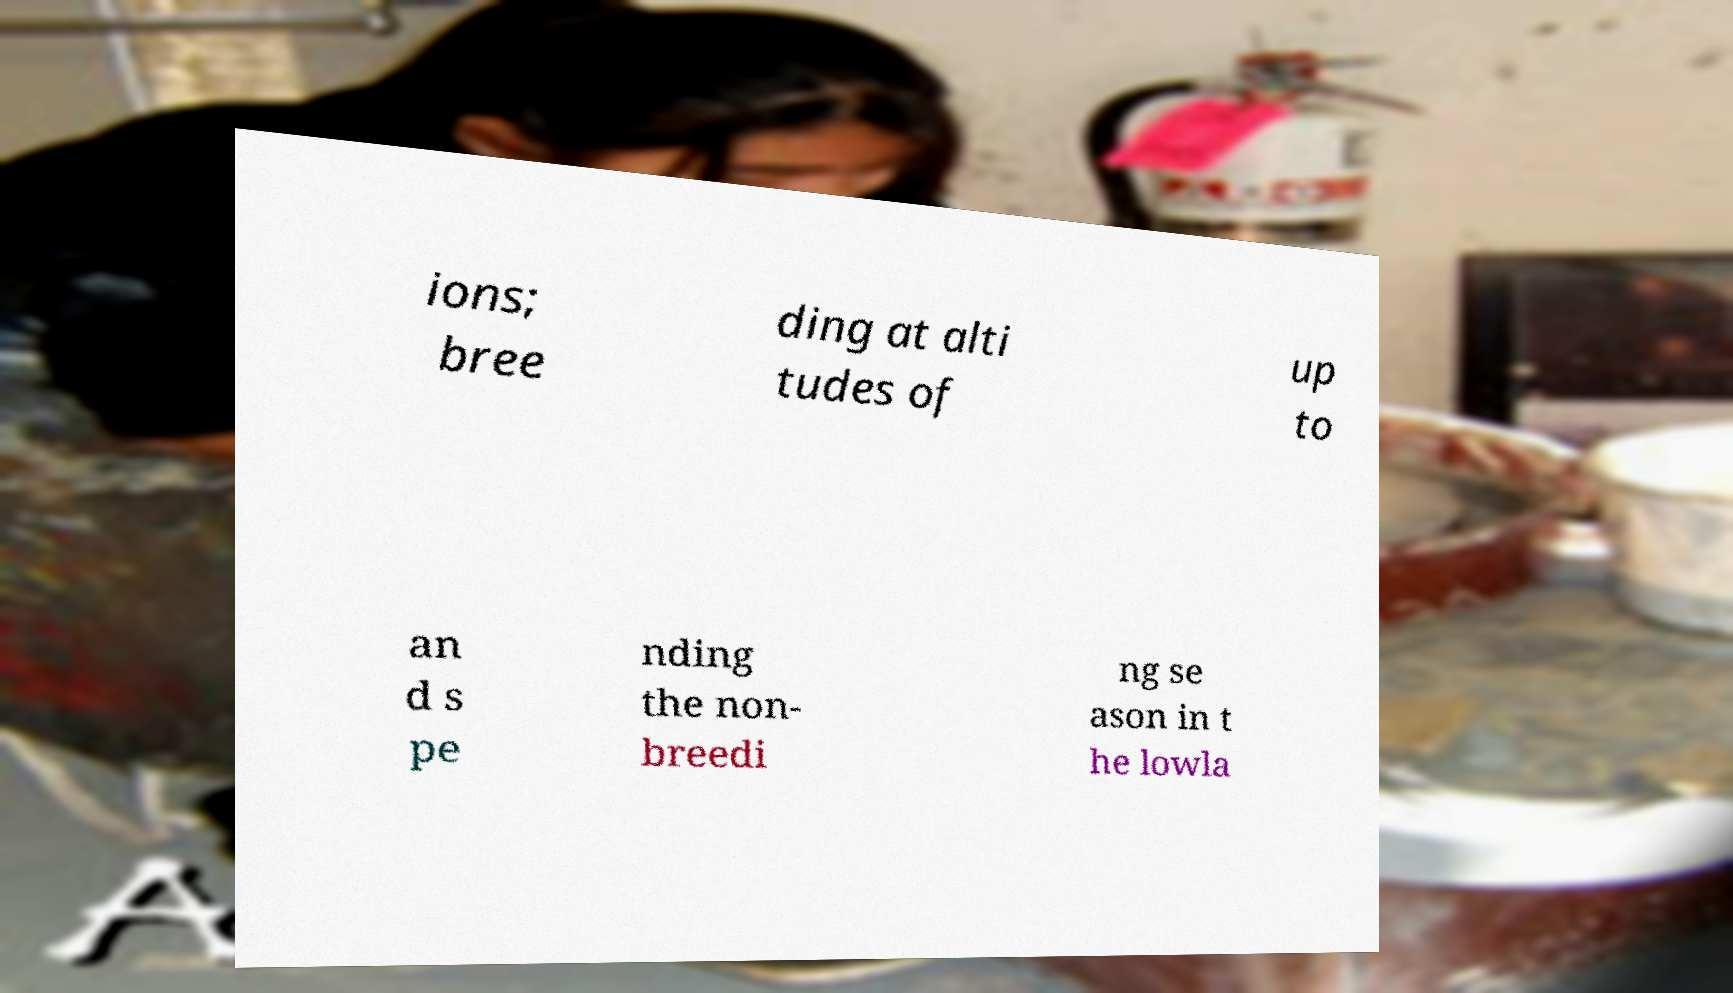Could you assist in decoding the text presented in this image and type it out clearly? ions; bree ding at alti tudes of up to an d s pe nding the non- breedi ng se ason in t he lowla 